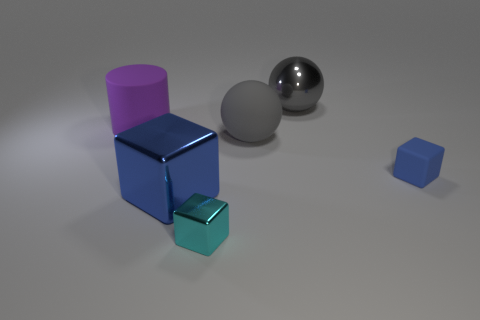Add 3 metallic things. How many objects exist? 9 Subtract all balls. How many objects are left? 4 Subtract all large brown blocks. Subtract all large cylinders. How many objects are left? 5 Add 1 matte cubes. How many matte cubes are left? 2 Add 2 purple cylinders. How many purple cylinders exist? 3 Subtract 0 blue cylinders. How many objects are left? 6 